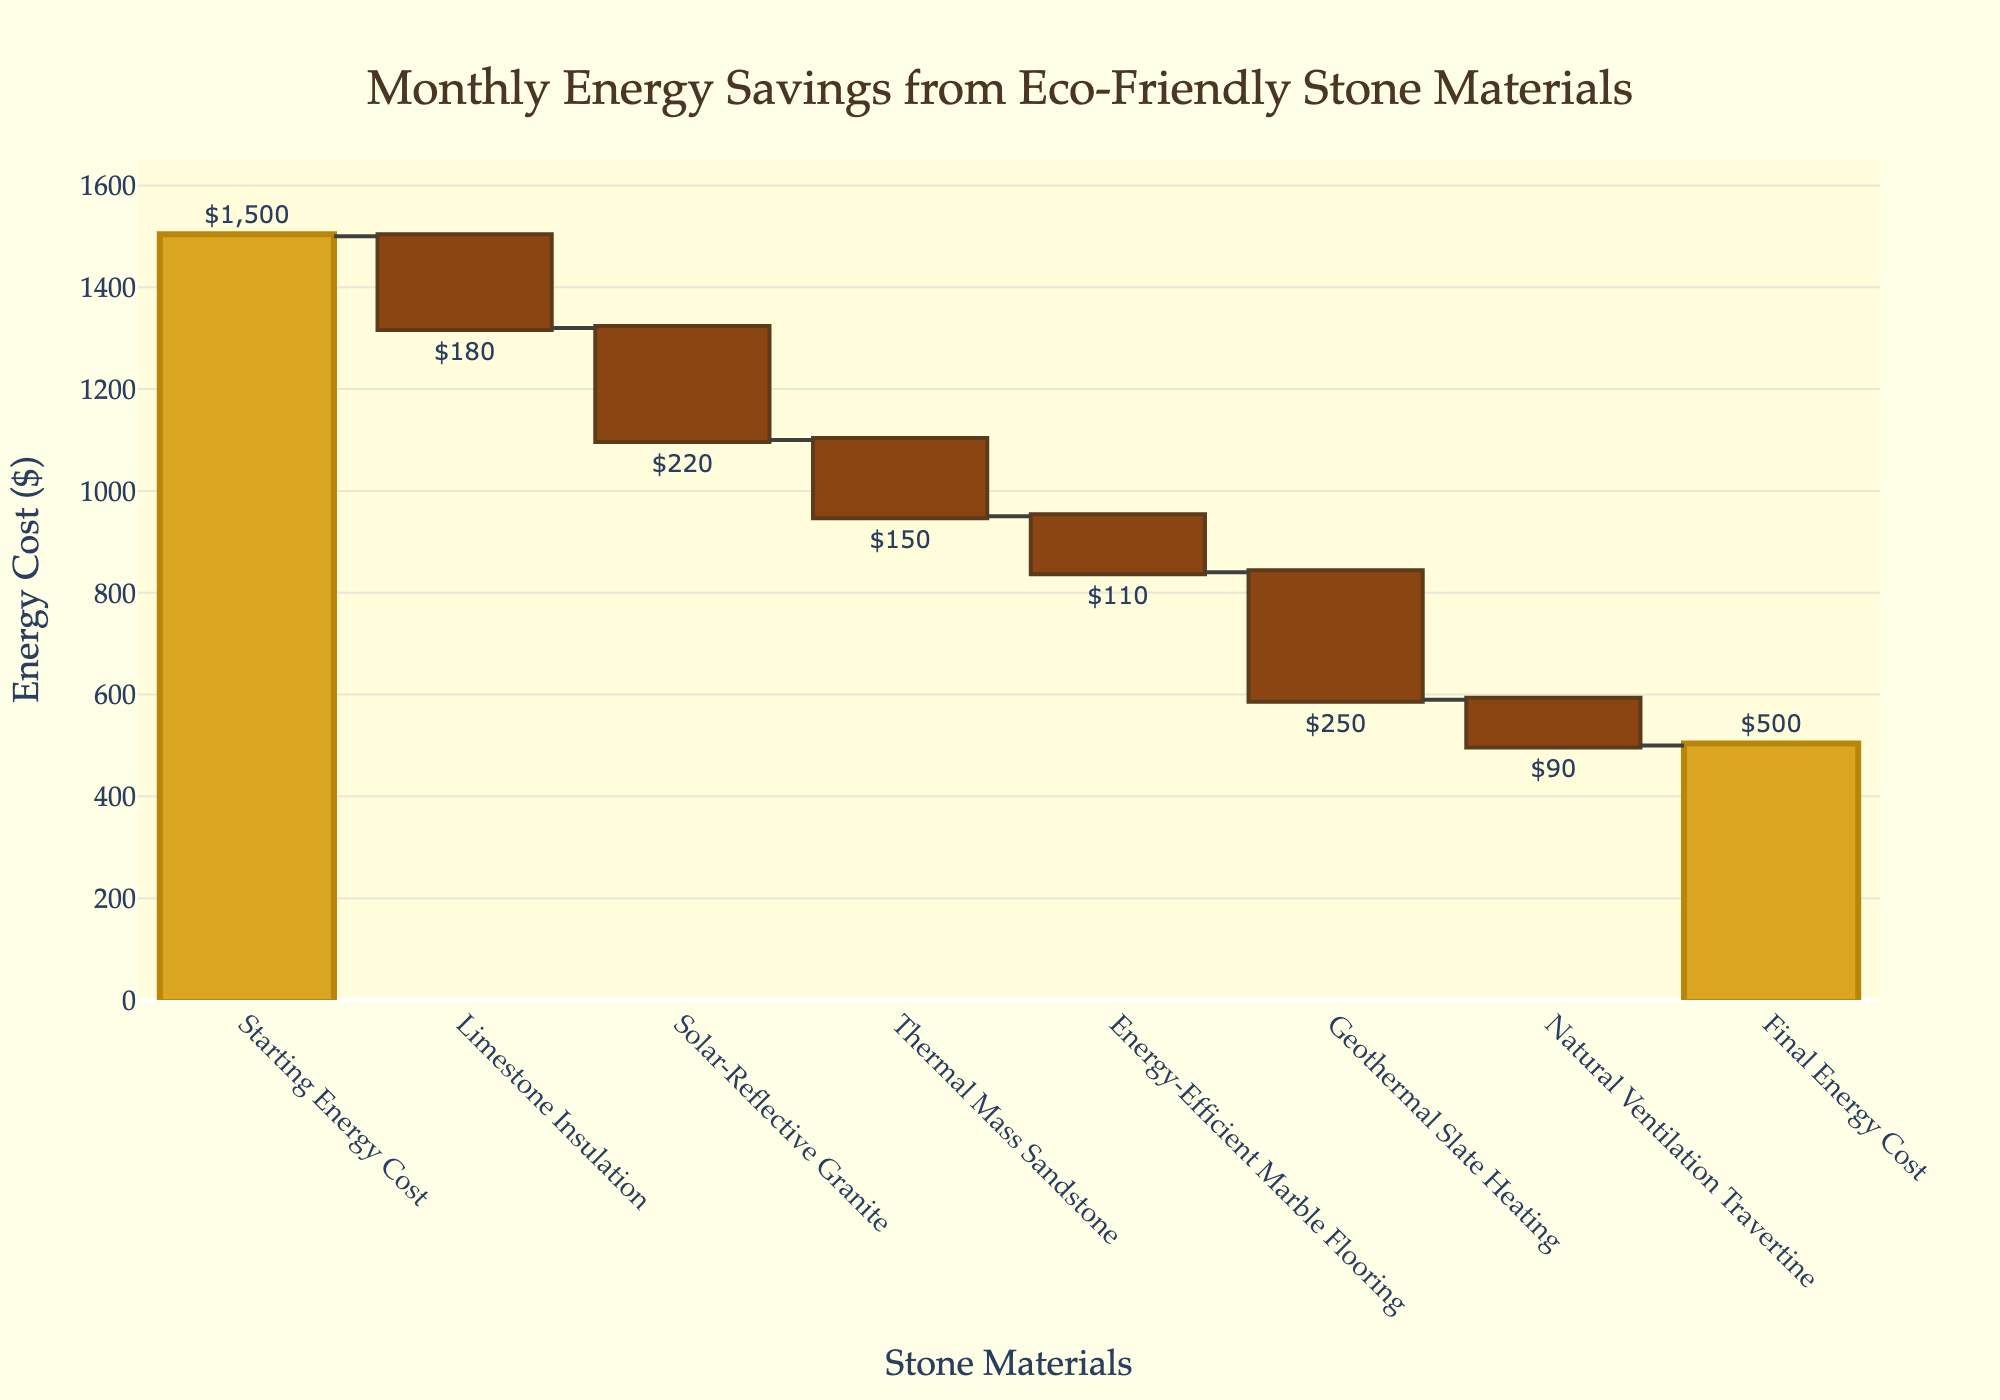How many categories are shown in the waterfall chart? The figure shows eight categories, which include "Starting Energy Cost," "Limestone Insulation," "Solar-Reflective Granite," "Thermal Mass Sandstone," "Energy-Efficient Marble Flooring," "Geothermal Slate Heating," "Natural Ventilation Travertine," and "Final Energy Cost."
Answer: 8 What is the title of the chart? The title is displayed at the top center of the chart and reads, "Monthly Energy Savings from Eco-Friendly Stone Materials."
Answer: Monthly Energy Savings from Eco-Friendly Stone Materials What is the total energy saving contributed by eco-friendly stone materials? The total energy savings are indicated by the difference between the "Starting Energy Cost" and the "Final Energy Cost." Starting cost is $1500, and the final cost is $500, so savings are $1500 - $500.
Answer: $1000 Which stone material contributed the highest energy savings? The stone material with the highest negative value under the "Energy Savings" category will be the highest contributor. "Geothermal Slate Heating" has the highest value at $250.
Answer: Geothermal Slate Heating What is the range of the y-axis in terms of energy cost? The range of the y-axis is from 0 to a value slightly higher than the maximum cumulative cost observed. The maximum cumulative cost is $1500, and the range goes slightly higher at $1650 to fit the chart.
Answer: 0 to $1650 How much energy cost reduction is achieved through Limestone Insulation? The value listed for "Limestone Insulation" in the figure is $180, indicating a reduction.
Answer: $180 Which materials together save more energy: Solar-Reflective Granite and Natural Ventilation Travertine or Geothermal Slate Heating alone? Sum the savings of "Solar-Reflective Granite" ($220) and "Natural Ventilation Travertine" ($90), which totals to $310. Compare this with "Geothermal Slate Heating," which is $250.
Answer: Solar-Reflective Granite and Natural Ventilation Travertine Are any materials contributing to an increase in energy costs? In a waterfall chart, increasing values would be shown in a different color (usually), and based on the description, no category value has a positive number indicating an increase.
Answer: No What is the average energy saving per stone material? Excluding the "Starting Energy Cost" and "Final Energy Cost," sum the individual savings: $180 + $220 + $150 + $110 + $250 + $90 = $1000. Divide by the number of materials, which is 6.
Answer: $166.67 By how much does the "Final Energy Cost" differ from the "Starting Energy Cost"? The "Final Energy Cost" is $500, and the "Starting Energy Cost" is $1500. Calculate the difference: $1500 - $500 = $1000.
Answer: $1000 